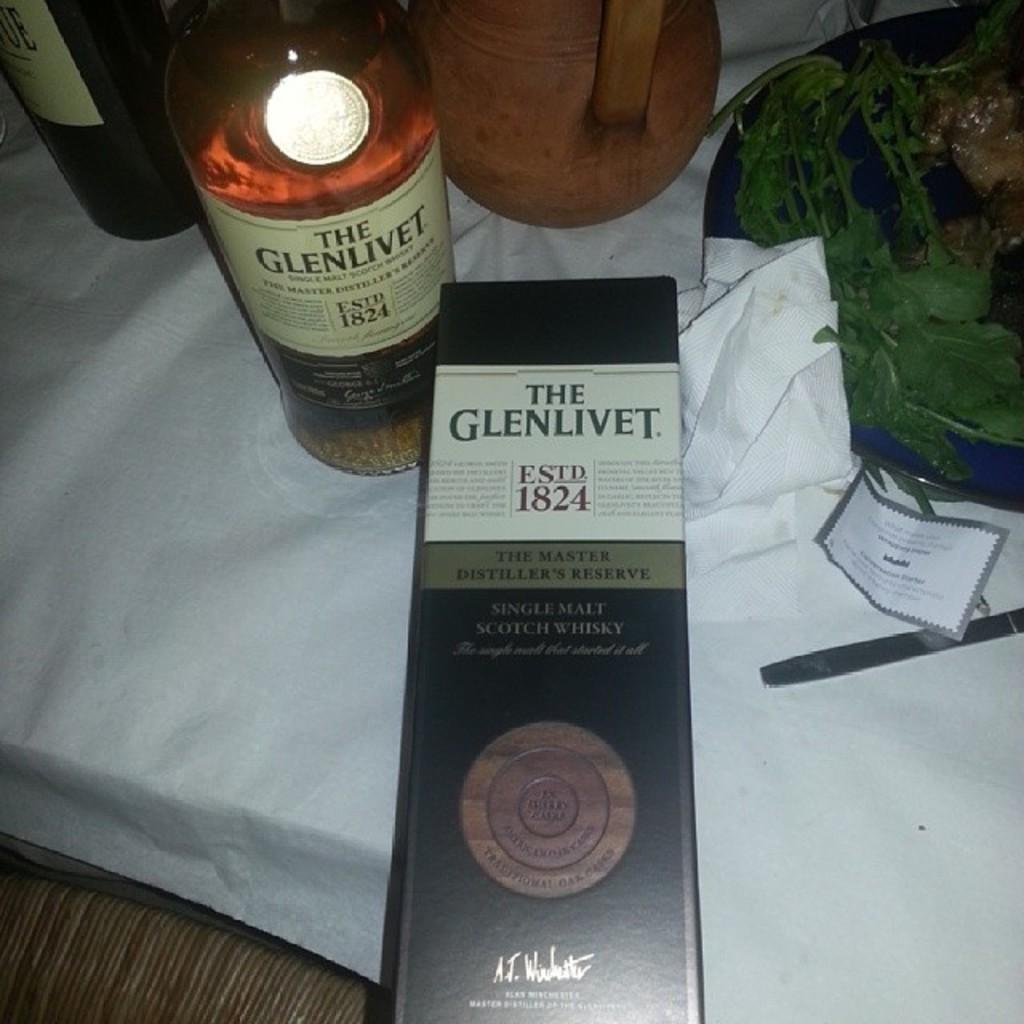Provide a one-sentence caption for the provided image. A bottle of Glenlivit sits on a table covered by a white cloth. 